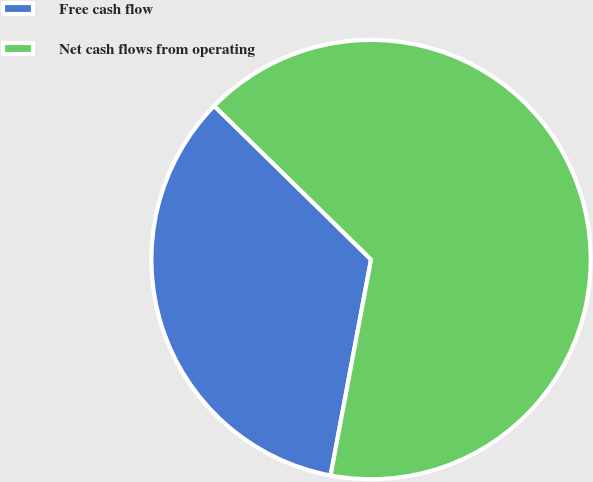<chart> <loc_0><loc_0><loc_500><loc_500><pie_chart><fcel>Free cash flow<fcel>Net cash flows from operating<nl><fcel>34.39%<fcel>65.61%<nl></chart> 